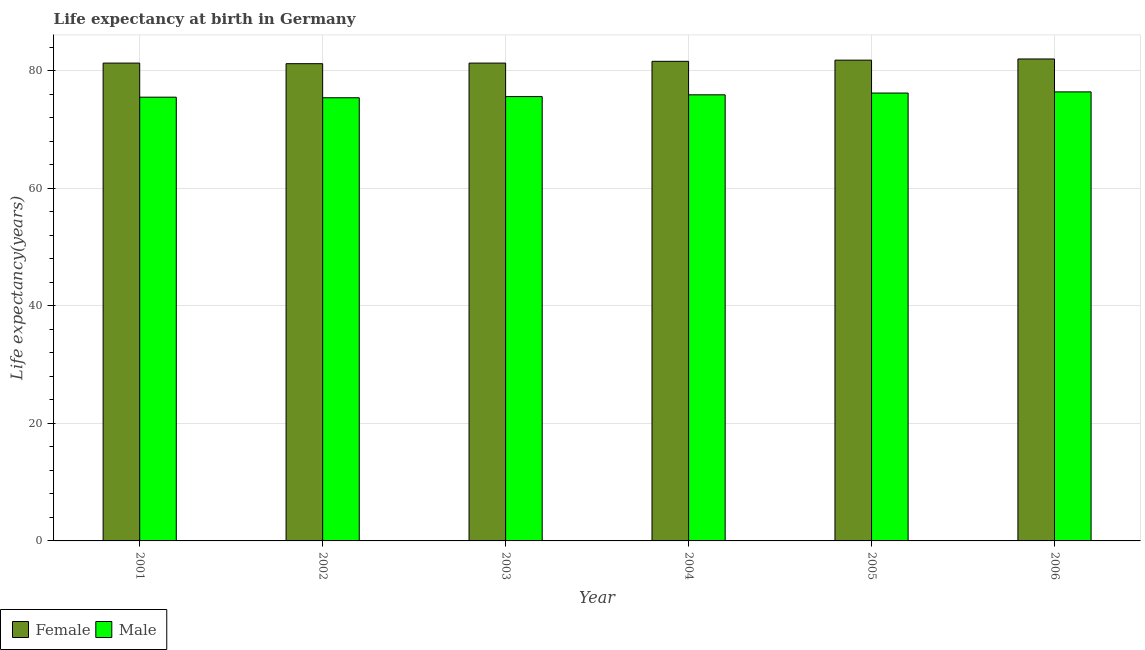How many different coloured bars are there?
Offer a terse response. 2. Are the number of bars per tick equal to the number of legend labels?
Provide a succinct answer. Yes. Are the number of bars on each tick of the X-axis equal?
Provide a short and direct response. Yes. What is the life expectancy(female) in 2005?
Your answer should be compact. 81.8. Across all years, what is the maximum life expectancy(male)?
Your response must be concise. 76.4. Across all years, what is the minimum life expectancy(male)?
Provide a succinct answer. 75.4. In which year was the life expectancy(male) maximum?
Your answer should be compact. 2006. In which year was the life expectancy(female) minimum?
Your answer should be very brief. 2002. What is the total life expectancy(female) in the graph?
Your answer should be very brief. 489.2. What is the difference between the life expectancy(female) in 2002 and that in 2003?
Offer a very short reply. -0.1. What is the average life expectancy(male) per year?
Offer a terse response. 75.83. In the year 2003, what is the difference between the life expectancy(female) and life expectancy(male)?
Your answer should be very brief. 0. What is the ratio of the life expectancy(male) in 2003 to that in 2004?
Offer a very short reply. 1. Is the life expectancy(male) in 2001 less than that in 2004?
Provide a short and direct response. Yes. What is the difference between the highest and the second highest life expectancy(female)?
Keep it short and to the point. 0.2. What is the difference between the highest and the lowest life expectancy(female)?
Provide a short and direct response. 0.8. Is the sum of the life expectancy(female) in 2002 and 2003 greater than the maximum life expectancy(male) across all years?
Your answer should be very brief. Yes. What does the 1st bar from the left in 2005 represents?
Provide a succinct answer. Female. Are all the bars in the graph horizontal?
Your response must be concise. No. Does the graph contain any zero values?
Make the answer very short. No. Where does the legend appear in the graph?
Give a very brief answer. Bottom left. How many legend labels are there?
Provide a short and direct response. 2. How are the legend labels stacked?
Make the answer very short. Horizontal. What is the title of the graph?
Make the answer very short. Life expectancy at birth in Germany. What is the label or title of the X-axis?
Offer a very short reply. Year. What is the label or title of the Y-axis?
Give a very brief answer. Life expectancy(years). What is the Life expectancy(years) in Female in 2001?
Your answer should be very brief. 81.3. What is the Life expectancy(years) of Male in 2001?
Keep it short and to the point. 75.5. What is the Life expectancy(years) of Female in 2002?
Provide a succinct answer. 81.2. What is the Life expectancy(years) in Male in 2002?
Your answer should be very brief. 75.4. What is the Life expectancy(years) in Female in 2003?
Make the answer very short. 81.3. What is the Life expectancy(years) of Male in 2003?
Provide a short and direct response. 75.6. What is the Life expectancy(years) of Female in 2004?
Give a very brief answer. 81.6. What is the Life expectancy(years) of Male in 2004?
Offer a terse response. 75.9. What is the Life expectancy(years) of Female in 2005?
Provide a succinct answer. 81.8. What is the Life expectancy(years) of Male in 2005?
Offer a terse response. 76.2. What is the Life expectancy(years) in Male in 2006?
Offer a very short reply. 76.4. Across all years, what is the maximum Life expectancy(years) of Male?
Provide a succinct answer. 76.4. Across all years, what is the minimum Life expectancy(years) in Female?
Ensure brevity in your answer.  81.2. Across all years, what is the minimum Life expectancy(years) in Male?
Provide a short and direct response. 75.4. What is the total Life expectancy(years) of Female in the graph?
Make the answer very short. 489.2. What is the total Life expectancy(years) in Male in the graph?
Make the answer very short. 455. What is the difference between the Life expectancy(years) of Male in 2001 and that in 2002?
Your response must be concise. 0.1. What is the difference between the Life expectancy(years) in Female in 2001 and that in 2003?
Your answer should be very brief. 0. What is the difference between the Life expectancy(years) of Male in 2001 and that in 2003?
Provide a short and direct response. -0.1. What is the difference between the Life expectancy(years) in Male in 2001 and that in 2004?
Ensure brevity in your answer.  -0.4. What is the difference between the Life expectancy(years) in Female in 2001 and that in 2006?
Offer a very short reply. -0.7. What is the difference between the Life expectancy(years) in Female in 2002 and that in 2004?
Ensure brevity in your answer.  -0.4. What is the difference between the Life expectancy(years) of Male in 2002 and that in 2004?
Provide a short and direct response. -0.5. What is the difference between the Life expectancy(years) of Female in 2002 and that in 2005?
Offer a terse response. -0.6. What is the difference between the Life expectancy(years) of Male in 2002 and that in 2005?
Keep it short and to the point. -0.8. What is the difference between the Life expectancy(years) of Male in 2002 and that in 2006?
Give a very brief answer. -1. What is the difference between the Life expectancy(years) in Male in 2003 and that in 2004?
Provide a short and direct response. -0.3. What is the difference between the Life expectancy(years) of Female in 2003 and that in 2005?
Your response must be concise. -0.5. What is the difference between the Life expectancy(years) of Male in 2003 and that in 2006?
Provide a short and direct response. -0.8. What is the difference between the Life expectancy(years) of Female in 2004 and that in 2006?
Offer a very short reply. -0.4. What is the difference between the Life expectancy(years) in Female in 2001 and the Life expectancy(years) in Male in 2004?
Provide a short and direct response. 5.4. What is the difference between the Life expectancy(years) of Female in 2002 and the Life expectancy(years) of Male in 2004?
Offer a very short reply. 5.3. What is the difference between the Life expectancy(years) in Female in 2002 and the Life expectancy(years) in Male in 2006?
Provide a short and direct response. 4.8. What is the difference between the Life expectancy(years) in Female in 2003 and the Life expectancy(years) in Male in 2004?
Your answer should be very brief. 5.4. What is the difference between the Life expectancy(years) of Female in 2005 and the Life expectancy(years) of Male in 2006?
Your response must be concise. 5.4. What is the average Life expectancy(years) of Female per year?
Provide a short and direct response. 81.53. What is the average Life expectancy(years) in Male per year?
Your response must be concise. 75.83. In the year 2002, what is the difference between the Life expectancy(years) of Female and Life expectancy(years) of Male?
Make the answer very short. 5.8. In the year 2004, what is the difference between the Life expectancy(years) of Female and Life expectancy(years) of Male?
Your answer should be compact. 5.7. In the year 2005, what is the difference between the Life expectancy(years) of Female and Life expectancy(years) of Male?
Give a very brief answer. 5.6. What is the ratio of the Life expectancy(years) of Female in 2001 to that in 2002?
Give a very brief answer. 1. What is the ratio of the Life expectancy(years) in Male in 2001 to that in 2002?
Provide a succinct answer. 1. What is the ratio of the Life expectancy(years) in Female in 2001 to that in 2003?
Your answer should be compact. 1. What is the ratio of the Life expectancy(years) of Female in 2001 to that in 2004?
Provide a succinct answer. 1. What is the ratio of the Life expectancy(years) of Female in 2001 to that in 2005?
Offer a very short reply. 0.99. What is the ratio of the Life expectancy(years) in Female in 2002 to that in 2003?
Provide a short and direct response. 1. What is the ratio of the Life expectancy(years) of Male in 2002 to that in 2005?
Your response must be concise. 0.99. What is the ratio of the Life expectancy(years) in Female in 2002 to that in 2006?
Keep it short and to the point. 0.99. What is the ratio of the Life expectancy(years) of Male in 2002 to that in 2006?
Offer a very short reply. 0.99. What is the ratio of the Life expectancy(years) of Female in 2003 to that in 2004?
Give a very brief answer. 1. What is the ratio of the Life expectancy(years) of Male in 2003 to that in 2004?
Offer a terse response. 1. What is the ratio of the Life expectancy(years) in Female in 2003 to that in 2005?
Your response must be concise. 0.99. What is the ratio of the Life expectancy(years) in Male in 2003 to that in 2005?
Provide a succinct answer. 0.99. What is the ratio of the Life expectancy(years) in Male in 2003 to that in 2006?
Your answer should be compact. 0.99. What is the ratio of the Life expectancy(years) in Female in 2004 to that in 2005?
Your answer should be very brief. 1. What is the ratio of the Life expectancy(years) in Female in 2004 to that in 2006?
Your answer should be very brief. 1. What is the ratio of the Life expectancy(years) of Male in 2004 to that in 2006?
Offer a terse response. 0.99. What is the difference between the highest and the second highest Life expectancy(years) in Female?
Make the answer very short. 0.2. What is the difference between the highest and the lowest Life expectancy(years) in Female?
Provide a short and direct response. 0.8. What is the difference between the highest and the lowest Life expectancy(years) in Male?
Provide a short and direct response. 1. 